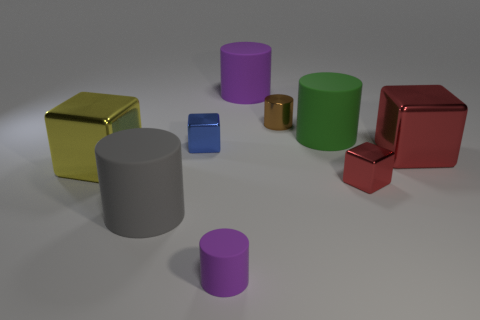There is a tiny matte thing that is the same shape as the brown metal thing; what color is it?
Make the answer very short. Purple. Does the matte thing that is on the left side of the small purple rubber cylinder have the same color as the large cube on the left side of the gray cylinder?
Give a very brief answer. No. Is the number of green cylinders in front of the blue block greater than the number of small matte objects?
Your answer should be compact. No. How many other objects are there of the same size as the blue block?
Provide a short and direct response. 3. How many rubber things are both left of the blue object and in front of the gray matte thing?
Give a very brief answer. 0. Is the material of the small cube to the right of the blue shiny object the same as the brown cylinder?
Give a very brief answer. Yes. There is a big rubber thing in front of the large metal block to the right of the cube that is to the left of the gray cylinder; what is its shape?
Provide a short and direct response. Cylinder. Is the number of large yellow metallic objects that are right of the green cylinder the same as the number of red cubes that are in front of the large gray rubber object?
Your answer should be very brief. Yes. What is the color of the other block that is the same size as the blue cube?
Make the answer very short. Red. How many large objects are either blue shiny blocks or gray metal balls?
Make the answer very short. 0. 